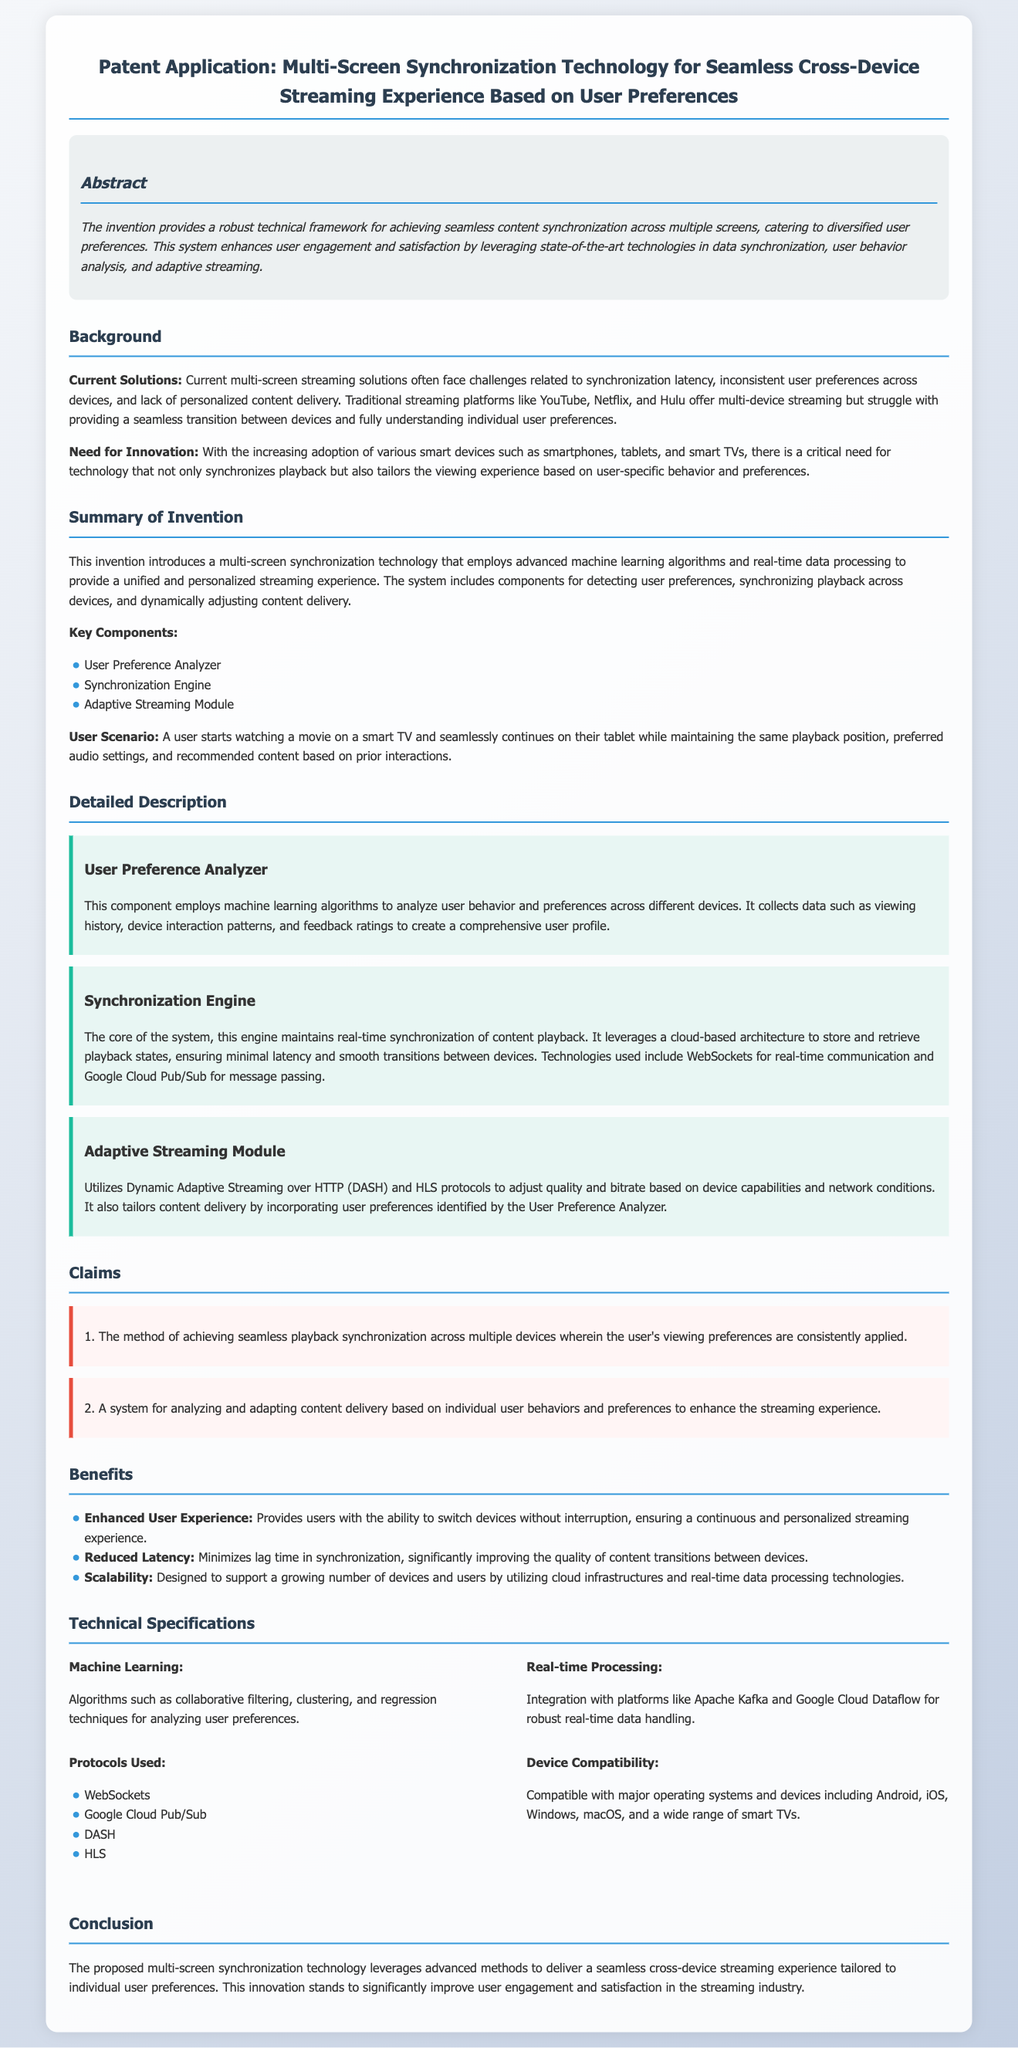What is the main purpose of the invention? The invention provides a robust technical framework for achieving seamless content synchronization across multiple screens, catering to diversified user preferences.
Answer: Seamless content synchronization What are the key components of the system? The document lists three key components: User Preference Analyzer, Synchronization Engine, and Adaptive Streaming Module.
Answer: User Preference Analyzer, Synchronization Engine, Adaptive Streaming Module Which protocols are used in the technology? The document mentions several protocols including WebSockets, Google Cloud Pub/Sub, DASH, and HLS.
Answer: WebSockets, Google Cloud Pub/Sub, DASH, HLS What is the primary benefit of reduced latency? The document states that reduced latency minimizes lag time in synchronization, significantly improving the quality of content transitions between devices.
Answer: Improved quality of content transitions How does the User Preference Analyzer work? This component employs machine learning algorithms to analyze user behavior and preferences across different devices, creating a comprehensive user profile.
Answer: Analyzes user behavior and preferences What is the user scenario described in the document? A user starts watching a movie on a smart TV and seamlessly continues on their tablet while maintaining the same playback position, preferred audio settings, and recommended content based on prior interactions.
Answer: Starts on smart TV, continues on tablet What is the claim made about seamless playback synchronization? The claim states the method of achieving seamless playback synchronization across multiple devices wherein the user's viewing preferences are consistently applied.
Answer: User's viewing preferences are consistently applied What does the Adaptive Streaming Module utilize? The Adaptive Streaming Module utilizes Dynamic Adaptive Streaming over HTTP (DASH) and HLS protocols.
Answer: DASH and HLS protocols What technologies are leveraged for real-time communication? The document specifies that the Synchronization Engine leverages WebSockets for real-time communication.
Answer: WebSockets 